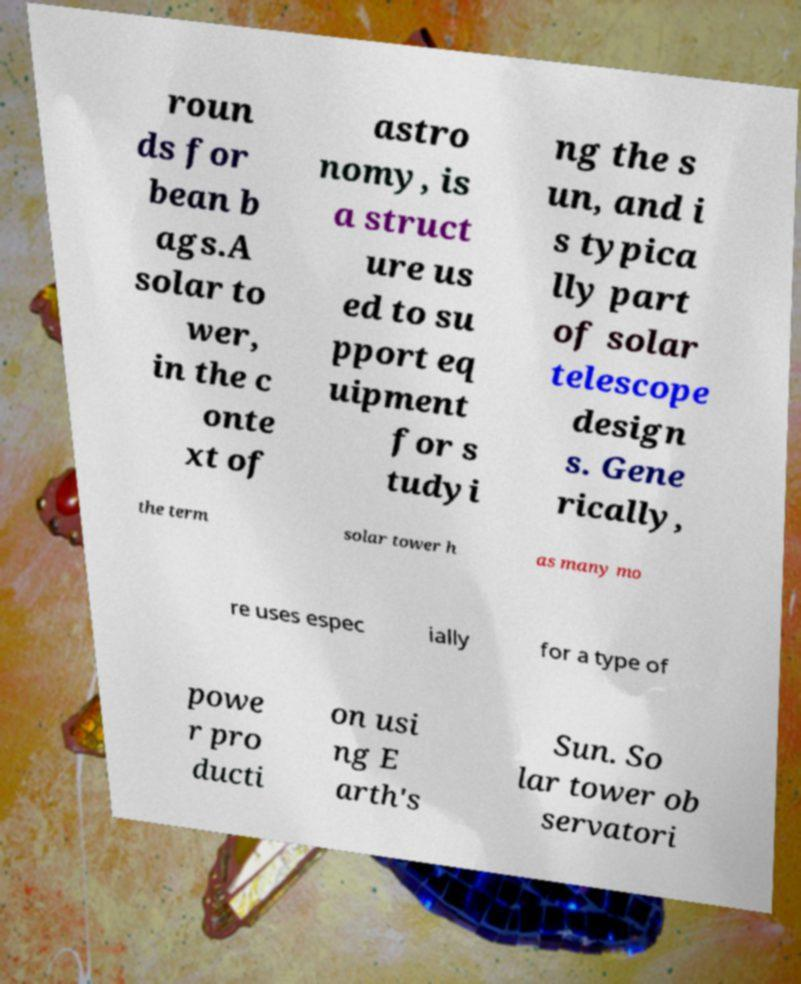Could you assist in decoding the text presented in this image and type it out clearly? roun ds for bean b ags.A solar to wer, in the c onte xt of astro nomy, is a struct ure us ed to su pport eq uipment for s tudyi ng the s un, and i s typica lly part of solar telescope design s. Gene rically, the term solar tower h as many mo re uses espec ially for a type of powe r pro ducti on usi ng E arth's Sun. So lar tower ob servatori 